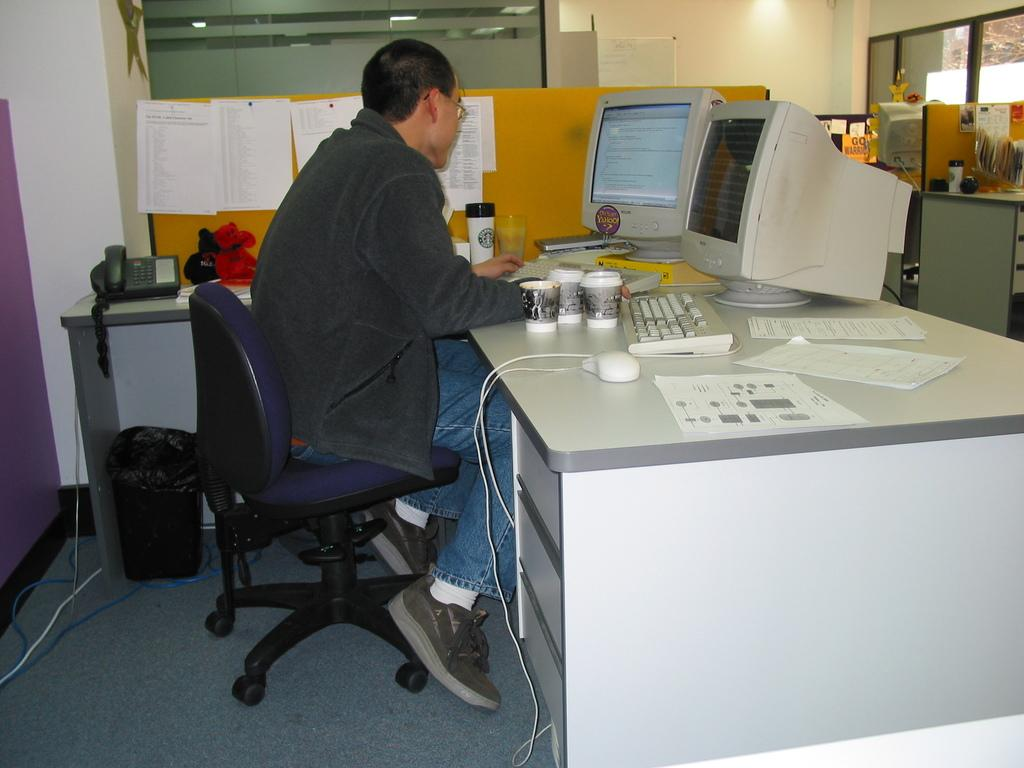What is the man in the image doing? The man is sitting on a chair in the image. What is located behind the man? The man is in front of a table. What electronic devices are on the table? There are two monitors on the table. What is used for typing on the table? There is a keyboard on the table. What other objects can be seen on the table? There are other objects on the table. How many dinosaurs are visible in the image? There are no dinosaurs present in the image. What type of smile does the man have in the image? The image does not show the man's facial expression, so it is not possible to determine if he is smiling or not. 